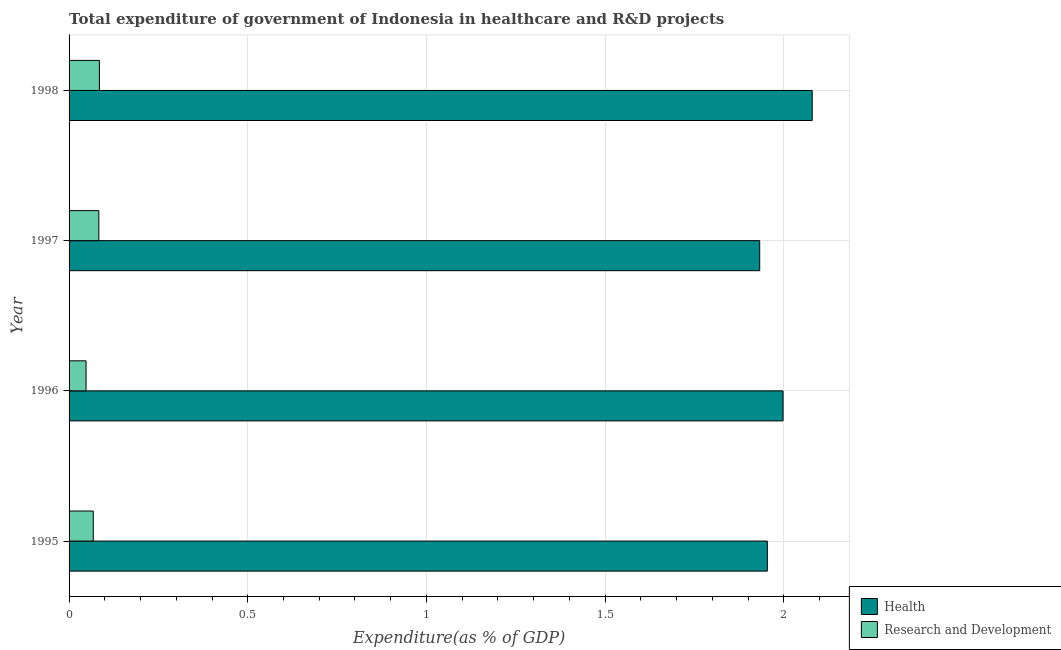How many different coloured bars are there?
Make the answer very short. 2. How many groups of bars are there?
Provide a succinct answer. 4. How many bars are there on the 1st tick from the bottom?
Keep it short and to the point. 2. What is the label of the 3rd group of bars from the top?
Provide a short and direct response. 1996. In how many cases, is the number of bars for a given year not equal to the number of legend labels?
Keep it short and to the point. 0. What is the expenditure in r&d in 1996?
Your response must be concise. 0.05. Across all years, what is the maximum expenditure in healthcare?
Your answer should be compact. 2.08. Across all years, what is the minimum expenditure in healthcare?
Give a very brief answer. 1.93. What is the total expenditure in healthcare in the graph?
Make the answer very short. 7.96. What is the difference between the expenditure in r&d in 1995 and that in 1997?
Your answer should be compact. -0.02. What is the difference between the expenditure in r&d in 1996 and the expenditure in healthcare in 1998?
Offer a very short reply. -2.03. What is the average expenditure in healthcare per year?
Make the answer very short. 1.99. In the year 1995, what is the difference between the expenditure in r&d and expenditure in healthcare?
Your answer should be compact. -1.89. In how many years, is the expenditure in r&d greater than 2 %?
Provide a short and direct response. 0. What is the ratio of the expenditure in healthcare in 1995 to that in 1996?
Keep it short and to the point. 0.98. Is the expenditure in healthcare in 1995 less than that in 1997?
Your answer should be compact. No. What is the difference between the highest and the second highest expenditure in r&d?
Provide a succinct answer. 0. What is the difference between the highest and the lowest expenditure in healthcare?
Offer a very short reply. 0.15. Is the sum of the expenditure in healthcare in 1996 and 1997 greater than the maximum expenditure in r&d across all years?
Your answer should be compact. Yes. What does the 2nd bar from the top in 1997 represents?
Keep it short and to the point. Health. What does the 2nd bar from the bottom in 1996 represents?
Ensure brevity in your answer.  Research and Development. How many bars are there?
Keep it short and to the point. 8. How many years are there in the graph?
Provide a succinct answer. 4. What is the difference between two consecutive major ticks on the X-axis?
Keep it short and to the point. 0.5. Are the values on the major ticks of X-axis written in scientific E-notation?
Your response must be concise. No. Does the graph contain grids?
Provide a succinct answer. Yes. How are the legend labels stacked?
Provide a succinct answer. Vertical. What is the title of the graph?
Your answer should be compact. Total expenditure of government of Indonesia in healthcare and R&D projects. Does "Mobile cellular" appear as one of the legend labels in the graph?
Your answer should be compact. No. What is the label or title of the X-axis?
Offer a terse response. Expenditure(as % of GDP). What is the Expenditure(as % of GDP) in Health in 1995?
Offer a very short reply. 1.95. What is the Expenditure(as % of GDP) in Research and Development in 1995?
Your response must be concise. 0.07. What is the Expenditure(as % of GDP) of Health in 1996?
Your answer should be very brief. 2. What is the Expenditure(as % of GDP) in Research and Development in 1996?
Your response must be concise. 0.05. What is the Expenditure(as % of GDP) in Health in 1997?
Offer a very short reply. 1.93. What is the Expenditure(as % of GDP) of Research and Development in 1997?
Your answer should be very brief. 0.08. What is the Expenditure(as % of GDP) of Health in 1998?
Provide a short and direct response. 2.08. What is the Expenditure(as % of GDP) of Research and Development in 1998?
Provide a succinct answer. 0.08. Across all years, what is the maximum Expenditure(as % of GDP) of Health?
Make the answer very short. 2.08. Across all years, what is the maximum Expenditure(as % of GDP) in Research and Development?
Offer a terse response. 0.08. Across all years, what is the minimum Expenditure(as % of GDP) in Health?
Keep it short and to the point. 1.93. Across all years, what is the minimum Expenditure(as % of GDP) in Research and Development?
Your answer should be very brief. 0.05. What is the total Expenditure(as % of GDP) in Health in the graph?
Your answer should be compact. 7.96. What is the total Expenditure(as % of GDP) in Research and Development in the graph?
Offer a terse response. 0.28. What is the difference between the Expenditure(as % of GDP) of Health in 1995 and that in 1996?
Give a very brief answer. -0.04. What is the difference between the Expenditure(as % of GDP) of Research and Development in 1995 and that in 1996?
Your answer should be very brief. 0.02. What is the difference between the Expenditure(as % of GDP) of Health in 1995 and that in 1997?
Offer a very short reply. 0.02. What is the difference between the Expenditure(as % of GDP) of Research and Development in 1995 and that in 1997?
Make the answer very short. -0.02. What is the difference between the Expenditure(as % of GDP) in Health in 1995 and that in 1998?
Give a very brief answer. -0.13. What is the difference between the Expenditure(as % of GDP) in Research and Development in 1995 and that in 1998?
Provide a short and direct response. -0.02. What is the difference between the Expenditure(as % of GDP) in Health in 1996 and that in 1997?
Ensure brevity in your answer.  0.07. What is the difference between the Expenditure(as % of GDP) in Research and Development in 1996 and that in 1997?
Provide a short and direct response. -0.04. What is the difference between the Expenditure(as % of GDP) in Health in 1996 and that in 1998?
Your answer should be compact. -0.08. What is the difference between the Expenditure(as % of GDP) of Research and Development in 1996 and that in 1998?
Offer a very short reply. -0.04. What is the difference between the Expenditure(as % of GDP) of Health in 1997 and that in 1998?
Your response must be concise. -0.15. What is the difference between the Expenditure(as % of GDP) in Research and Development in 1997 and that in 1998?
Offer a very short reply. -0. What is the difference between the Expenditure(as % of GDP) of Health in 1995 and the Expenditure(as % of GDP) of Research and Development in 1996?
Ensure brevity in your answer.  1.91. What is the difference between the Expenditure(as % of GDP) in Health in 1995 and the Expenditure(as % of GDP) in Research and Development in 1997?
Ensure brevity in your answer.  1.87. What is the difference between the Expenditure(as % of GDP) in Health in 1995 and the Expenditure(as % of GDP) in Research and Development in 1998?
Your response must be concise. 1.87. What is the difference between the Expenditure(as % of GDP) of Health in 1996 and the Expenditure(as % of GDP) of Research and Development in 1997?
Give a very brief answer. 1.91. What is the difference between the Expenditure(as % of GDP) of Health in 1996 and the Expenditure(as % of GDP) of Research and Development in 1998?
Make the answer very short. 1.91. What is the difference between the Expenditure(as % of GDP) in Health in 1997 and the Expenditure(as % of GDP) in Research and Development in 1998?
Offer a terse response. 1.85. What is the average Expenditure(as % of GDP) in Health per year?
Your answer should be very brief. 1.99. What is the average Expenditure(as % of GDP) of Research and Development per year?
Provide a succinct answer. 0.07. In the year 1995, what is the difference between the Expenditure(as % of GDP) in Health and Expenditure(as % of GDP) in Research and Development?
Your answer should be very brief. 1.89. In the year 1996, what is the difference between the Expenditure(as % of GDP) of Health and Expenditure(as % of GDP) of Research and Development?
Give a very brief answer. 1.95. In the year 1997, what is the difference between the Expenditure(as % of GDP) in Health and Expenditure(as % of GDP) in Research and Development?
Provide a short and direct response. 1.85. In the year 1998, what is the difference between the Expenditure(as % of GDP) of Health and Expenditure(as % of GDP) of Research and Development?
Your answer should be very brief. 1.99. What is the ratio of the Expenditure(as % of GDP) in Health in 1995 to that in 1996?
Provide a short and direct response. 0.98. What is the ratio of the Expenditure(as % of GDP) in Research and Development in 1995 to that in 1996?
Provide a succinct answer. 1.42. What is the ratio of the Expenditure(as % of GDP) of Health in 1995 to that in 1997?
Offer a very short reply. 1.01. What is the ratio of the Expenditure(as % of GDP) in Research and Development in 1995 to that in 1997?
Offer a terse response. 0.81. What is the ratio of the Expenditure(as % of GDP) in Health in 1995 to that in 1998?
Your answer should be very brief. 0.94. What is the ratio of the Expenditure(as % of GDP) in Research and Development in 1995 to that in 1998?
Make the answer very short. 0.8. What is the ratio of the Expenditure(as % of GDP) of Health in 1996 to that in 1997?
Provide a succinct answer. 1.03. What is the ratio of the Expenditure(as % of GDP) in Research and Development in 1996 to that in 1997?
Provide a short and direct response. 0.57. What is the ratio of the Expenditure(as % of GDP) in Health in 1996 to that in 1998?
Ensure brevity in your answer.  0.96. What is the ratio of the Expenditure(as % of GDP) in Research and Development in 1996 to that in 1998?
Your response must be concise. 0.56. What is the ratio of the Expenditure(as % of GDP) in Health in 1997 to that in 1998?
Provide a succinct answer. 0.93. What is the ratio of the Expenditure(as % of GDP) in Research and Development in 1997 to that in 1998?
Offer a very short reply. 0.98. What is the difference between the highest and the second highest Expenditure(as % of GDP) of Health?
Ensure brevity in your answer.  0.08. What is the difference between the highest and the second highest Expenditure(as % of GDP) of Research and Development?
Your response must be concise. 0. What is the difference between the highest and the lowest Expenditure(as % of GDP) of Health?
Ensure brevity in your answer.  0.15. What is the difference between the highest and the lowest Expenditure(as % of GDP) of Research and Development?
Offer a very short reply. 0.04. 